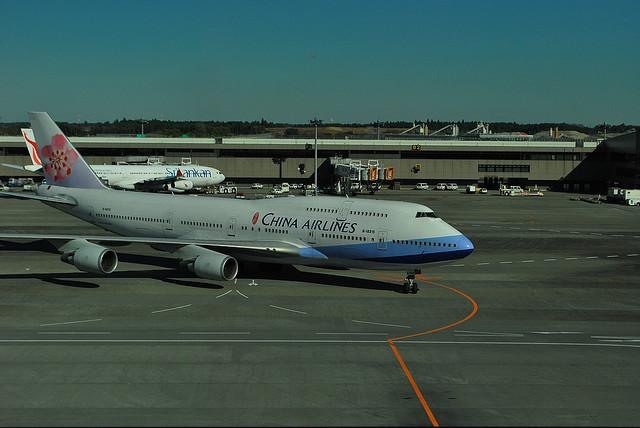Is the plane at it's gate?
Concise answer only. No. What airline does the airplane belong to?
Write a very short answer. China airlines. Where is the 3M logo?
Give a very brief answer. Nowhere. Is it overcast or sunny?
Give a very brief answer. Overcast. What does it say on the plane?
Concise answer only. China airlines. What is on the tail of the airplane?
Quick response, please. Flower. Is this plane landing?
Be succinct. No. What is written on the side of the plane?
Answer briefly. China airlines. How many planes?
Write a very short answer. 2. What company owns the plane?
Answer briefly. China airlines. Is this a recent photo?
Keep it brief. Yes. How many people can fit inside the plane?
Keep it brief. 300. Is the plane in motion?
Short answer required. No. Is this a commercial plane?
Give a very brief answer. Yes. What letters are on the plane?
Keep it brief. China airlines. What color is the nose of the plane?
Quick response, please. Blue. What word is displayed near the front of the jet?
Be succinct. China airlines. What is written on the plane?
Short answer required. China airlines. Is it foggy?
Quick response, please. No. How many airlines are represented in this image?
Keep it brief. 2. How many colors is the plane's tail?
Be succinct. 2. What is the name of the airline on the closest plane?
Be succinct. China airlines. Is the plane white and red?
Concise answer only. No. Is that a private plane?
Quick response, please. No. 